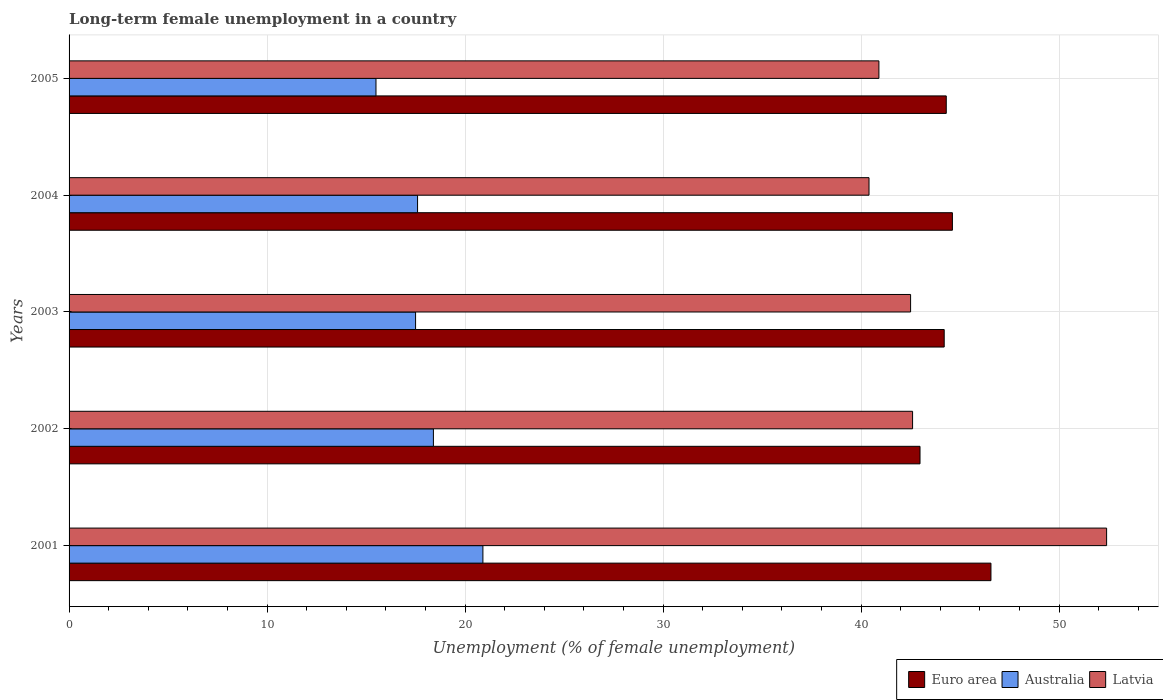How many different coloured bars are there?
Your response must be concise. 3. Are the number of bars per tick equal to the number of legend labels?
Ensure brevity in your answer.  Yes. Are the number of bars on each tick of the Y-axis equal?
Keep it short and to the point. Yes. How many bars are there on the 1st tick from the bottom?
Your answer should be very brief. 3. In how many cases, is the number of bars for a given year not equal to the number of legend labels?
Your response must be concise. 0. What is the percentage of long-term unemployed female population in Euro area in 2005?
Your answer should be compact. 44.3. Across all years, what is the maximum percentage of long-term unemployed female population in Australia?
Keep it short and to the point. 20.9. Across all years, what is the minimum percentage of long-term unemployed female population in Latvia?
Give a very brief answer. 40.4. In which year was the percentage of long-term unemployed female population in Euro area minimum?
Ensure brevity in your answer.  2002. What is the total percentage of long-term unemployed female population in Australia in the graph?
Provide a succinct answer. 89.9. What is the difference between the percentage of long-term unemployed female population in Australia in 2004 and that in 2005?
Provide a short and direct response. 2.1. What is the difference between the percentage of long-term unemployed female population in Euro area in 2005 and the percentage of long-term unemployed female population in Australia in 2003?
Provide a short and direct response. 26.8. What is the average percentage of long-term unemployed female population in Australia per year?
Offer a terse response. 17.98. In the year 2001, what is the difference between the percentage of long-term unemployed female population in Australia and percentage of long-term unemployed female population in Latvia?
Your answer should be compact. -31.5. In how many years, is the percentage of long-term unemployed female population in Latvia greater than 14 %?
Provide a succinct answer. 5. What is the ratio of the percentage of long-term unemployed female population in Latvia in 2004 to that in 2005?
Your response must be concise. 0.99. What is the difference between the highest and the second highest percentage of long-term unemployed female population in Australia?
Ensure brevity in your answer.  2.5. What is the difference between the highest and the lowest percentage of long-term unemployed female population in Latvia?
Provide a succinct answer. 12. What does the 3rd bar from the bottom in 2001 represents?
Offer a very short reply. Latvia. How many years are there in the graph?
Give a very brief answer. 5. Are the values on the major ticks of X-axis written in scientific E-notation?
Ensure brevity in your answer.  No. Where does the legend appear in the graph?
Your answer should be very brief. Bottom right. How are the legend labels stacked?
Your answer should be very brief. Horizontal. What is the title of the graph?
Your response must be concise. Long-term female unemployment in a country. Does "Cayman Islands" appear as one of the legend labels in the graph?
Ensure brevity in your answer.  No. What is the label or title of the X-axis?
Your response must be concise. Unemployment (% of female unemployment). What is the Unemployment (% of female unemployment) of Euro area in 2001?
Keep it short and to the point. 46.56. What is the Unemployment (% of female unemployment) in Australia in 2001?
Your response must be concise. 20.9. What is the Unemployment (% of female unemployment) of Latvia in 2001?
Make the answer very short. 52.4. What is the Unemployment (% of female unemployment) of Euro area in 2002?
Offer a very short reply. 42.98. What is the Unemployment (% of female unemployment) in Australia in 2002?
Provide a succinct answer. 18.4. What is the Unemployment (% of female unemployment) in Latvia in 2002?
Provide a succinct answer. 42.6. What is the Unemployment (% of female unemployment) of Euro area in 2003?
Give a very brief answer. 44.2. What is the Unemployment (% of female unemployment) of Australia in 2003?
Your response must be concise. 17.5. What is the Unemployment (% of female unemployment) in Latvia in 2003?
Your answer should be very brief. 42.5. What is the Unemployment (% of female unemployment) in Euro area in 2004?
Ensure brevity in your answer.  44.61. What is the Unemployment (% of female unemployment) of Australia in 2004?
Your answer should be compact. 17.6. What is the Unemployment (% of female unemployment) of Latvia in 2004?
Give a very brief answer. 40.4. What is the Unemployment (% of female unemployment) in Euro area in 2005?
Provide a succinct answer. 44.3. What is the Unemployment (% of female unemployment) of Latvia in 2005?
Your answer should be very brief. 40.9. Across all years, what is the maximum Unemployment (% of female unemployment) of Euro area?
Give a very brief answer. 46.56. Across all years, what is the maximum Unemployment (% of female unemployment) in Australia?
Offer a terse response. 20.9. Across all years, what is the maximum Unemployment (% of female unemployment) of Latvia?
Your answer should be compact. 52.4. Across all years, what is the minimum Unemployment (% of female unemployment) in Euro area?
Ensure brevity in your answer.  42.98. Across all years, what is the minimum Unemployment (% of female unemployment) of Latvia?
Give a very brief answer. 40.4. What is the total Unemployment (% of female unemployment) in Euro area in the graph?
Give a very brief answer. 222.65. What is the total Unemployment (% of female unemployment) of Australia in the graph?
Your answer should be compact. 89.9. What is the total Unemployment (% of female unemployment) of Latvia in the graph?
Provide a succinct answer. 218.8. What is the difference between the Unemployment (% of female unemployment) of Euro area in 2001 and that in 2002?
Provide a succinct answer. 3.58. What is the difference between the Unemployment (% of female unemployment) in Australia in 2001 and that in 2002?
Provide a short and direct response. 2.5. What is the difference between the Unemployment (% of female unemployment) in Latvia in 2001 and that in 2002?
Offer a terse response. 9.8. What is the difference between the Unemployment (% of female unemployment) of Euro area in 2001 and that in 2003?
Ensure brevity in your answer.  2.36. What is the difference between the Unemployment (% of female unemployment) in Latvia in 2001 and that in 2003?
Give a very brief answer. 9.9. What is the difference between the Unemployment (% of female unemployment) of Euro area in 2001 and that in 2004?
Provide a short and direct response. 1.95. What is the difference between the Unemployment (% of female unemployment) of Australia in 2001 and that in 2004?
Your answer should be very brief. 3.3. What is the difference between the Unemployment (% of female unemployment) of Euro area in 2001 and that in 2005?
Your answer should be very brief. 2.26. What is the difference between the Unemployment (% of female unemployment) in Australia in 2001 and that in 2005?
Ensure brevity in your answer.  5.4. What is the difference between the Unemployment (% of female unemployment) of Euro area in 2002 and that in 2003?
Give a very brief answer. -1.22. What is the difference between the Unemployment (% of female unemployment) of Australia in 2002 and that in 2003?
Your answer should be very brief. 0.9. What is the difference between the Unemployment (% of female unemployment) of Latvia in 2002 and that in 2003?
Offer a very short reply. 0.1. What is the difference between the Unemployment (% of female unemployment) in Euro area in 2002 and that in 2004?
Offer a terse response. -1.64. What is the difference between the Unemployment (% of female unemployment) in Australia in 2002 and that in 2004?
Your response must be concise. 0.8. What is the difference between the Unemployment (% of female unemployment) in Latvia in 2002 and that in 2004?
Your answer should be compact. 2.2. What is the difference between the Unemployment (% of female unemployment) of Euro area in 2002 and that in 2005?
Give a very brief answer. -1.33. What is the difference between the Unemployment (% of female unemployment) in Australia in 2002 and that in 2005?
Ensure brevity in your answer.  2.9. What is the difference between the Unemployment (% of female unemployment) of Latvia in 2002 and that in 2005?
Offer a terse response. 1.7. What is the difference between the Unemployment (% of female unemployment) in Euro area in 2003 and that in 2004?
Make the answer very short. -0.41. What is the difference between the Unemployment (% of female unemployment) in Australia in 2003 and that in 2004?
Offer a very short reply. -0.1. What is the difference between the Unemployment (% of female unemployment) of Latvia in 2003 and that in 2004?
Make the answer very short. 2.1. What is the difference between the Unemployment (% of female unemployment) in Euro area in 2003 and that in 2005?
Provide a succinct answer. -0.1. What is the difference between the Unemployment (% of female unemployment) in Australia in 2003 and that in 2005?
Your answer should be very brief. 2. What is the difference between the Unemployment (% of female unemployment) in Latvia in 2003 and that in 2005?
Keep it short and to the point. 1.6. What is the difference between the Unemployment (% of female unemployment) of Euro area in 2004 and that in 2005?
Give a very brief answer. 0.31. What is the difference between the Unemployment (% of female unemployment) of Australia in 2004 and that in 2005?
Offer a very short reply. 2.1. What is the difference between the Unemployment (% of female unemployment) of Latvia in 2004 and that in 2005?
Ensure brevity in your answer.  -0.5. What is the difference between the Unemployment (% of female unemployment) in Euro area in 2001 and the Unemployment (% of female unemployment) in Australia in 2002?
Your response must be concise. 28.16. What is the difference between the Unemployment (% of female unemployment) of Euro area in 2001 and the Unemployment (% of female unemployment) of Latvia in 2002?
Ensure brevity in your answer.  3.96. What is the difference between the Unemployment (% of female unemployment) in Australia in 2001 and the Unemployment (% of female unemployment) in Latvia in 2002?
Give a very brief answer. -21.7. What is the difference between the Unemployment (% of female unemployment) in Euro area in 2001 and the Unemployment (% of female unemployment) in Australia in 2003?
Your answer should be compact. 29.06. What is the difference between the Unemployment (% of female unemployment) of Euro area in 2001 and the Unemployment (% of female unemployment) of Latvia in 2003?
Keep it short and to the point. 4.06. What is the difference between the Unemployment (% of female unemployment) in Australia in 2001 and the Unemployment (% of female unemployment) in Latvia in 2003?
Ensure brevity in your answer.  -21.6. What is the difference between the Unemployment (% of female unemployment) in Euro area in 2001 and the Unemployment (% of female unemployment) in Australia in 2004?
Provide a short and direct response. 28.96. What is the difference between the Unemployment (% of female unemployment) in Euro area in 2001 and the Unemployment (% of female unemployment) in Latvia in 2004?
Keep it short and to the point. 6.16. What is the difference between the Unemployment (% of female unemployment) in Australia in 2001 and the Unemployment (% of female unemployment) in Latvia in 2004?
Provide a short and direct response. -19.5. What is the difference between the Unemployment (% of female unemployment) of Euro area in 2001 and the Unemployment (% of female unemployment) of Australia in 2005?
Provide a short and direct response. 31.06. What is the difference between the Unemployment (% of female unemployment) in Euro area in 2001 and the Unemployment (% of female unemployment) in Latvia in 2005?
Give a very brief answer. 5.66. What is the difference between the Unemployment (% of female unemployment) in Euro area in 2002 and the Unemployment (% of female unemployment) in Australia in 2003?
Provide a short and direct response. 25.48. What is the difference between the Unemployment (% of female unemployment) in Euro area in 2002 and the Unemployment (% of female unemployment) in Latvia in 2003?
Your response must be concise. 0.48. What is the difference between the Unemployment (% of female unemployment) in Australia in 2002 and the Unemployment (% of female unemployment) in Latvia in 2003?
Provide a succinct answer. -24.1. What is the difference between the Unemployment (% of female unemployment) in Euro area in 2002 and the Unemployment (% of female unemployment) in Australia in 2004?
Make the answer very short. 25.38. What is the difference between the Unemployment (% of female unemployment) in Euro area in 2002 and the Unemployment (% of female unemployment) in Latvia in 2004?
Ensure brevity in your answer.  2.58. What is the difference between the Unemployment (% of female unemployment) of Euro area in 2002 and the Unemployment (% of female unemployment) of Australia in 2005?
Make the answer very short. 27.48. What is the difference between the Unemployment (% of female unemployment) in Euro area in 2002 and the Unemployment (% of female unemployment) in Latvia in 2005?
Your response must be concise. 2.08. What is the difference between the Unemployment (% of female unemployment) of Australia in 2002 and the Unemployment (% of female unemployment) of Latvia in 2005?
Make the answer very short. -22.5. What is the difference between the Unemployment (% of female unemployment) in Euro area in 2003 and the Unemployment (% of female unemployment) in Australia in 2004?
Provide a succinct answer. 26.6. What is the difference between the Unemployment (% of female unemployment) in Euro area in 2003 and the Unemployment (% of female unemployment) in Latvia in 2004?
Ensure brevity in your answer.  3.8. What is the difference between the Unemployment (% of female unemployment) of Australia in 2003 and the Unemployment (% of female unemployment) of Latvia in 2004?
Your response must be concise. -22.9. What is the difference between the Unemployment (% of female unemployment) in Euro area in 2003 and the Unemployment (% of female unemployment) in Australia in 2005?
Ensure brevity in your answer.  28.7. What is the difference between the Unemployment (% of female unemployment) of Euro area in 2003 and the Unemployment (% of female unemployment) of Latvia in 2005?
Ensure brevity in your answer.  3.3. What is the difference between the Unemployment (% of female unemployment) of Australia in 2003 and the Unemployment (% of female unemployment) of Latvia in 2005?
Your response must be concise. -23.4. What is the difference between the Unemployment (% of female unemployment) in Euro area in 2004 and the Unemployment (% of female unemployment) in Australia in 2005?
Give a very brief answer. 29.11. What is the difference between the Unemployment (% of female unemployment) in Euro area in 2004 and the Unemployment (% of female unemployment) in Latvia in 2005?
Provide a succinct answer. 3.71. What is the difference between the Unemployment (% of female unemployment) of Australia in 2004 and the Unemployment (% of female unemployment) of Latvia in 2005?
Give a very brief answer. -23.3. What is the average Unemployment (% of female unemployment) in Euro area per year?
Make the answer very short. 44.53. What is the average Unemployment (% of female unemployment) in Australia per year?
Offer a very short reply. 17.98. What is the average Unemployment (% of female unemployment) of Latvia per year?
Make the answer very short. 43.76. In the year 2001, what is the difference between the Unemployment (% of female unemployment) in Euro area and Unemployment (% of female unemployment) in Australia?
Give a very brief answer. 25.66. In the year 2001, what is the difference between the Unemployment (% of female unemployment) of Euro area and Unemployment (% of female unemployment) of Latvia?
Make the answer very short. -5.84. In the year 2001, what is the difference between the Unemployment (% of female unemployment) of Australia and Unemployment (% of female unemployment) of Latvia?
Provide a succinct answer. -31.5. In the year 2002, what is the difference between the Unemployment (% of female unemployment) in Euro area and Unemployment (% of female unemployment) in Australia?
Your answer should be very brief. 24.58. In the year 2002, what is the difference between the Unemployment (% of female unemployment) of Euro area and Unemployment (% of female unemployment) of Latvia?
Provide a short and direct response. 0.38. In the year 2002, what is the difference between the Unemployment (% of female unemployment) in Australia and Unemployment (% of female unemployment) in Latvia?
Your response must be concise. -24.2. In the year 2003, what is the difference between the Unemployment (% of female unemployment) of Euro area and Unemployment (% of female unemployment) of Australia?
Provide a succinct answer. 26.7. In the year 2003, what is the difference between the Unemployment (% of female unemployment) in Euro area and Unemployment (% of female unemployment) in Latvia?
Offer a very short reply. 1.7. In the year 2004, what is the difference between the Unemployment (% of female unemployment) in Euro area and Unemployment (% of female unemployment) in Australia?
Offer a terse response. 27.01. In the year 2004, what is the difference between the Unemployment (% of female unemployment) in Euro area and Unemployment (% of female unemployment) in Latvia?
Provide a succinct answer. 4.21. In the year 2004, what is the difference between the Unemployment (% of female unemployment) in Australia and Unemployment (% of female unemployment) in Latvia?
Make the answer very short. -22.8. In the year 2005, what is the difference between the Unemployment (% of female unemployment) of Euro area and Unemployment (% of female unemployment) of Australia?
Your answer should be compact. 28.8. In the year 2005, what is the difference between the Unemployment (% of female unemployment) in Euro area and Unemployment (% of female unemployment) in Latvia?
Keep it short and to the point. 3.4. In the year 2005, what is the difference between the Unemployment (% of female unemployment) in Australia and Unemployment (% of female unemployment) in Latvia?
Your response must be concise. -25.4. What is the ratio of the Unemployment (% of female unemployment) in Euro area in 2001 to that in 2002?
Give a very brief answer. 1.08. What is the ratio of the Unemployment (% of female unemployment) of Australia in 2001 to that in 2002?
Make the answer very short. 1.14. What is the ratio of the Unemployment (% of female unemployment) in Latvia in 2001 to that in 2002?
Your answer should be very brief. 1.23. What is the ratio of the Unemployment (% of female unemployment) of Euro area in 2001 to that in 2003?
Offer a terse response. 1.05. What is the ratio of the Unemployment (% of female unemployment) in Australia in 2001 to that in 2003?
Your answer should be very brief. 1.19. What is the ratio of the Unemployment (% of female unemployment) of Latvia in 2001 to that in 2003?
Give a very brief answer. 1.23. What is the ratio of the Unemployment (% of female unemployment) of Euro area in 2001 to that in 2004?
Your response must be concise. 1.04. What is the ratio of the Unemployment (% of female unemployment) in Australia in 2001 to that in 2004?
Offer a very short reply. 1.19. What is the ratio of the Unemployment (% of female unemployment) in Latvia in 2001 to that in 2004?
Your answer should be very brief. 1.3. What is the ratio of the Unemployment (% of female unemployment) of Euro area in 2001 to that in 2005?
Make the answer very short. 1.05. What is the ratio of the Unemployment (% of female unemployment) of Australia in 2001 to that in 2005?
Make the answer very short. 1.35. What is the ratio of the Unemployment (% of female unemployment) in Latvia in 2001 to that in 2005?
Ensure brevity in your answer.  1.28. What is the ratio of the Unemployment (% of female unemployment) in Euro area in 2002 to that in 2003?
Keep it short and to the point. 0.97. What is the ratio of the Unemployment (% of female unemployment) of Australia in 2002 to that in 2003?
Ensure brevity in your answer.  1.05. What is the ratio of the Unemployment (% of female unemployment) of Euro area in 2002 to that in 2004?
Your answer should be compact. 0.96. What is the ratio of the Unemployment (% of female unemployment) of Australia in 2002 to that in 2004?
Provide a short and direct response. 1.05. What is the ratio of the Unemployment (% of female unemployment) in Latvia in 2002 to that in 2004?
Your response must be concise. 1.05. What is the ratio of the Unemployment (% of female unemployment) in Euro area in 2002 to that in 2005?
Provide a succinct answer. 0.97. What is the ratio of the Unemployment (% of female unemployment) of Australia in 2002 to that in 2005?
Your answer should be very brief. 1.19. What is the ratio of the Unemployment (% of female unemployment) of Latvia in 2002 to that in 2005?
Ensure brevity in your answer.  1.04. What is the ratio of the Unemployment (% of female unemployment) of Euro area in 2003 to that in 2004?
Keep it short and to the point. 0.99. What is the ratio of the Unemployment (% of female unemployment) of Latvia in 2003 to that in 2004?
Give a very brief answer. 1.05. What is the ratio of the Unemployment (% of female unemployment) of Euro area in 2003 to that in 2005?
Your answer should be very brief. 1. What is the ratio of the Unemployment (% of female unemployment) in Australia in 2003 to that in 2005?
Your answer should be very brief. 1.13. What is the ratio of the Unemployment (% of female unemployment) in Latvia in 2003 to that in 2005?
Your answer should be very brief. 1.04. What is the ratio of the Unemployment (% of female unemployment) of Australia in 2004 to that in 2005?
Your response must be concise. 1.14. What is the ratio of the Unemployment (% of female unemployment) in Latvia in 2004 to that in 2005?
Offer a very short reply. 0.99. What is the difference between the highest and the second highest Unemployment (% of female unemployment) of Euro area?
Offer a very short reply. 1.95. What is the difference between the highest and the second highest Unemployment (% of female unemployment) of Latvia?
Provide a succinct answer. 9.8. What is the difference between the highest and the lowest Unemployment (% of female unemployment) of Euro area?
Offer a very short reply. 3.58. 